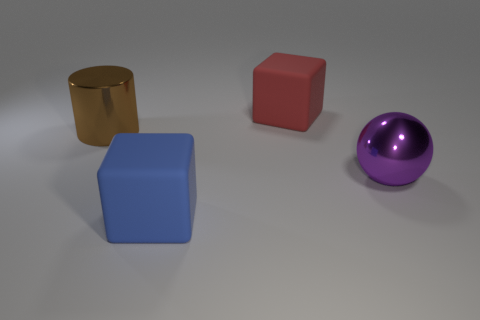What is the shape of the purple metallic thing?
Offer a terse response. Sphere. What is the material of the big cube right of the matte block that is in front of the block that is behind the big blue rubber object?
Your answer should be very brief. Rubber. How many purple things are large matte cubes or metal spheres?
Keep it short and to the point. 1. What number of big objects are either shiny spheres or gray shiny cylinders?
Ensure brevity in your answer.  1. Is the block in front of the big sphere made of the same material as the cube behind the large blue object?
Offer a terse response. Yes. There is a large purple sphere that is behind the blue matte thing; what material is it?
Provide a succinct answer. Metal. What number of metallic objects are blue blocks or small red things?
Provide a succinct answer. 0. There is a metal thing that is left of the large object that is behind the big brown cylinder; what is its color?
Your answer should be very brief. Brown. Are the purple thing and the big thing on the left side of the large blue object made of the same material?
Offer a terse response. Yes. There is a rubber thing that is in front of the large shiny object that is to the right of the large cube in front of the purple object; what is its color?
Make the answer very short. Blue. 